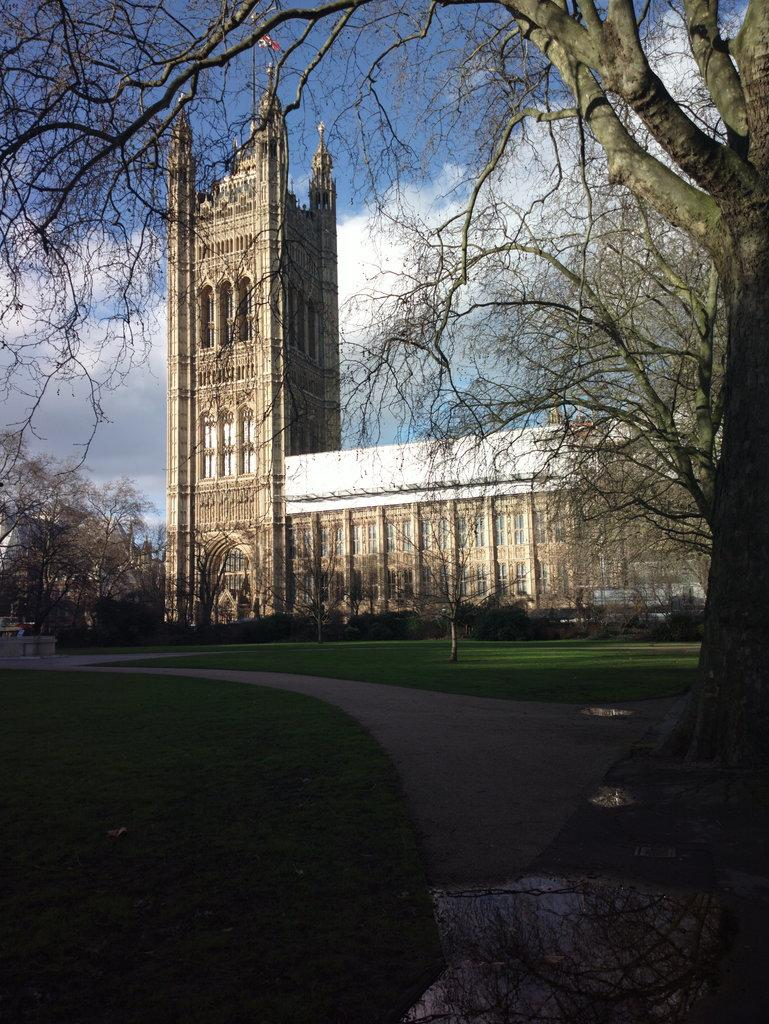What type of vegetation is present in the image? There is grass in the image. What can be seen besides the grass in the image? There is a pathway, trees, and a stone building in the image. What is visible in the background of the image? The sky is visible in the background of the image, and there are clouds in the sky. Where is the shelf located in the image? There is no shelf present in the image. What type of bedroom can be seen in the image? There is no bedroom present in the image. 